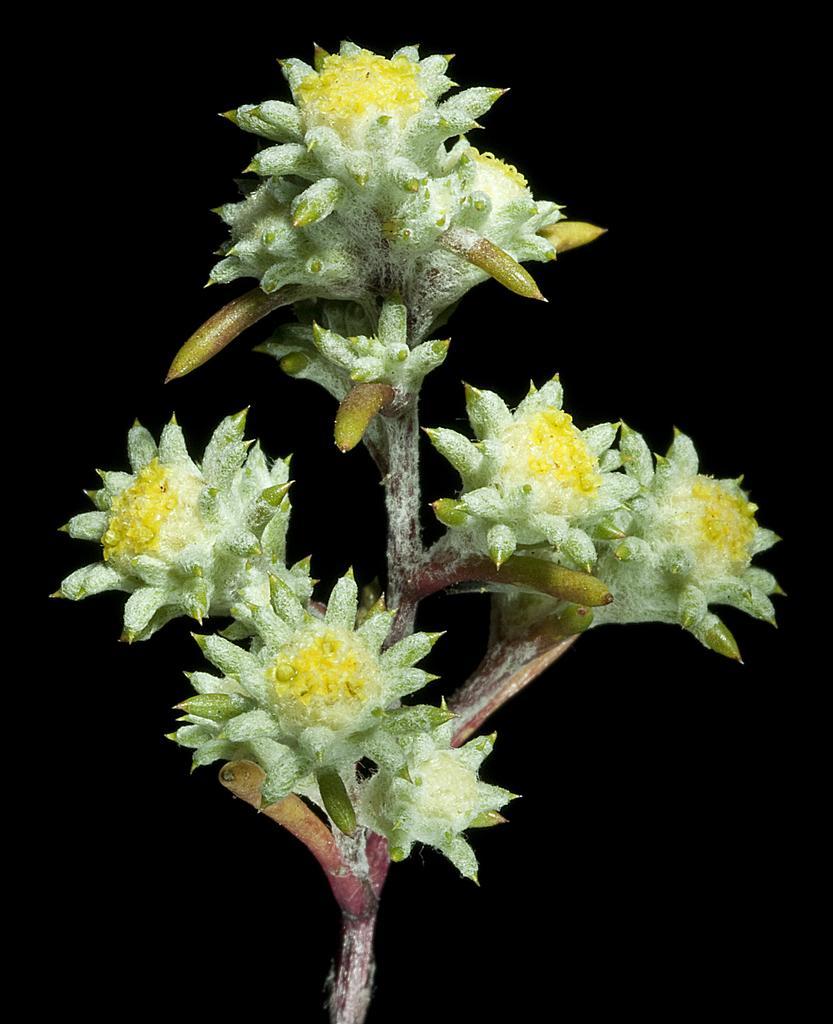Could you give a brief overview of what you see in this image? In the picture we can see a plant with different kind of flowers to it and behind it we can see dark. 